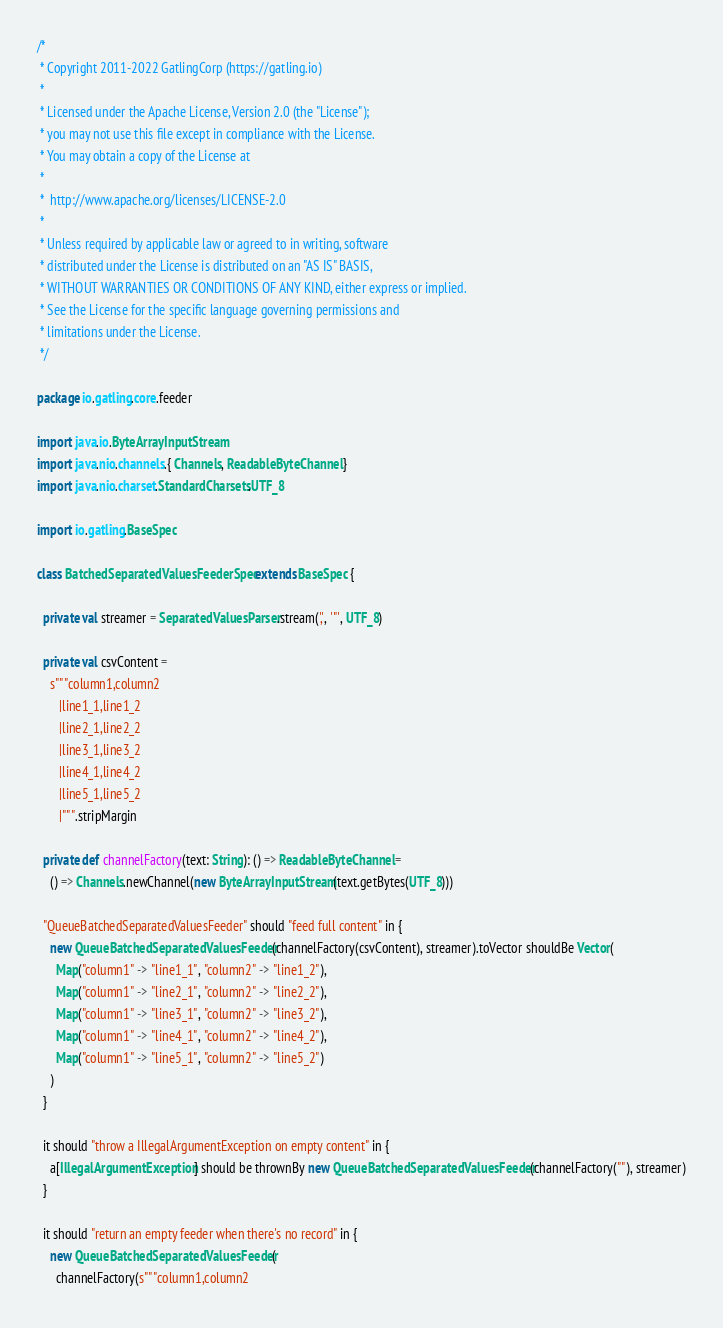Convert code to text. <code><loc_0><loc_0><loc_500><loc_500><_Scala_>/*
 * Copyright 2011-2022 GatlingCorp (https://gatling.io)
 *
 * Licensed under the Apache License, Version 2.0 (the "License");
 * you may not use this file except in compliance with the License.
 * You may obtain a copy of the License at
 *
 *  http://www.apache.org/licenses/LICENSE-2.0
 *
 * Unless required by applicable law or agreed to in writing, software
 * distributed under the License is distributed on an "AS IS" BASIS,
 * WITHOUT WARRANTIES OR CONDITIONS OF ANY KIND, either express or implied.
 * See the License for the specific language governing permissions and
 * limitations under the License.
 */

package io.gatling.core.feeder

import java.io.ByteArrayInputStream
import java.nio.channels.{ Channels, ReadableByteChannel }
import java.nio.charset.StandardCharsets.UTF_8

import io.gatling.BaseSpec

class BatchedSeparatedValuesFeederSpec extends BaseSpec {

  private val streamer = SeparatedValuesParser.stream(',', '"', UTF_8)

  private val csvContent =
    s"""column1,column2
       |line1_1,line1_2
       |line2_1,line2_2
       |line3_1,line3_2
       |line4_1,line4_2
       |line5_1,line5_2
       |""".stripMargin

  private def channelFactory(text: String): () => ReadableByteChannel =
    () => Channels.newChannel(new ByteArrayInputStream(text.getBytes(UTF_8)))

  "QueueBatchedSeparatedValuesFeeder" should "feed full content" in {
    new QueueBatchedSeparatedValuesFeeder(channelFactory(csvContent), streamer).toVector shouldBe Vector(
      Map("column1" -> "line1_1", "column2" -> "line1_2"),
      Map("column1" -> "line2_1", "column2" -> "line2_2"),
      Map("column1" -> "line3_1", "column2" -> "line3_2"),
      Map("column1" -> "line4_1", "column2" -> "line4_2"),
      Map("column1" -> "line5_1", "column2" -> "line5_2")
    )
  }

  it should "throw a IllegalArgumentException on empty content" in {
    a[IllegalArgumentException] should be thrownBy new QueueBatchedSeparatedValuesFeeder(channelFactory(""), streamer)
  }

  it should "return an empty feeder when there's no record" in {
    new QueueBatchedSeparatedValuesFeeder(
      channelFactory(s"""column1,column2</code> 